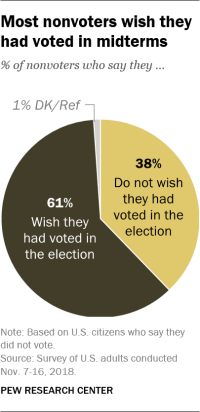Outline some significant characteristics in this image. The color of the second largest segment is yellow. 